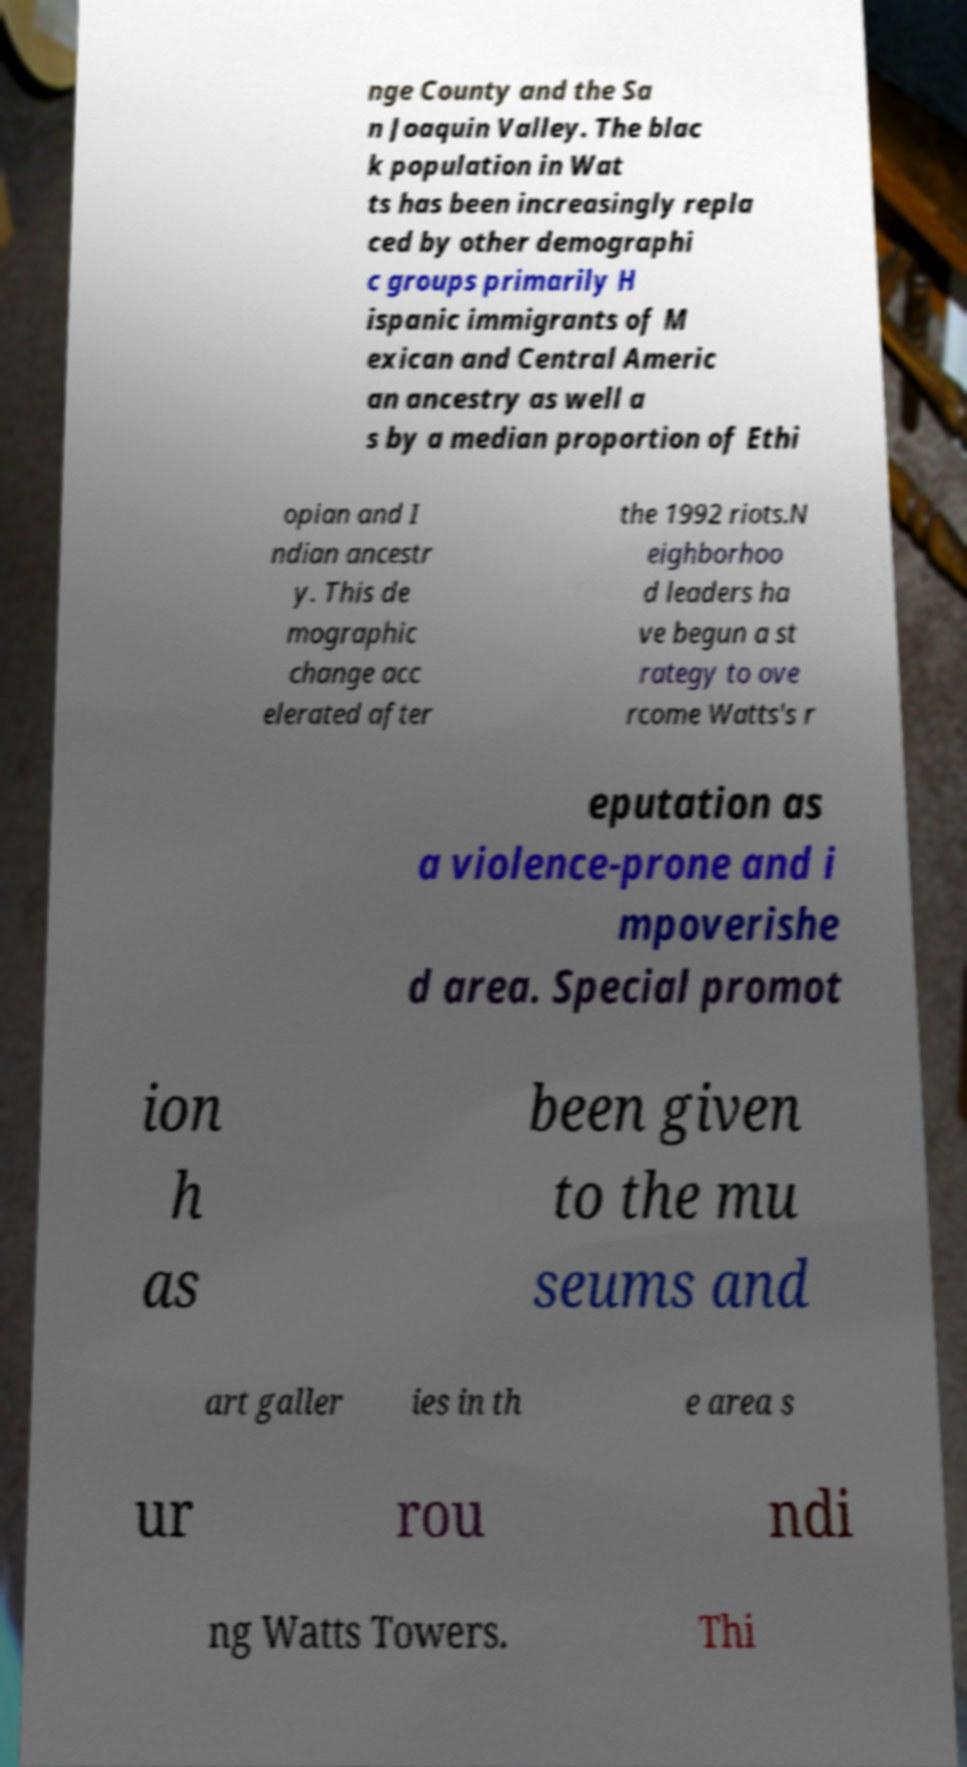Can you read and provide the text displayed in the image?This photo seems to have some interesting text. Can you extract and type it out for me? nge County and the Sa n Joaquin Valley. The blac k population in Wat ts has been increasingly repla ced by other demographi c groups primarily H ispanic immigrants of M exican and Central Americ an ancestry as well a s by a median proportion of Ethi opian and I ndian ancestr y. This de mographic change acc elerated after the 1992 riots.N eighborhoo d leaders ha ve begun a st rategy to ove rcome Watts's r eputation as a violence-prone and i mpoverishe d area. Special promot ion h as been given to the mu seums and art galler ies in th e area s ur rou ndi ng Watts Towers. Thi 